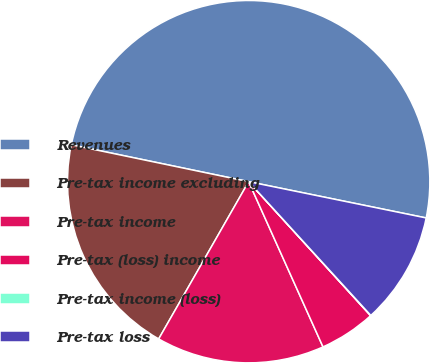Convert chart. <chart><loc_0><loc_0><loc_500><loc_500><pie_chart><fcel>Revenues<fcel>Pre-tax income excluding<fcel>Pre-tax income<fcel>Pre-tax (loss) income<fcel>Pre-tax income (loss)<fcel>Pre-tax loss<nl><fcel>49.94%<fcel>19.99%<fcel>15.0%<fcel>5.02%<fcel>0.03%<fcel>10.01%<nl></chart> 